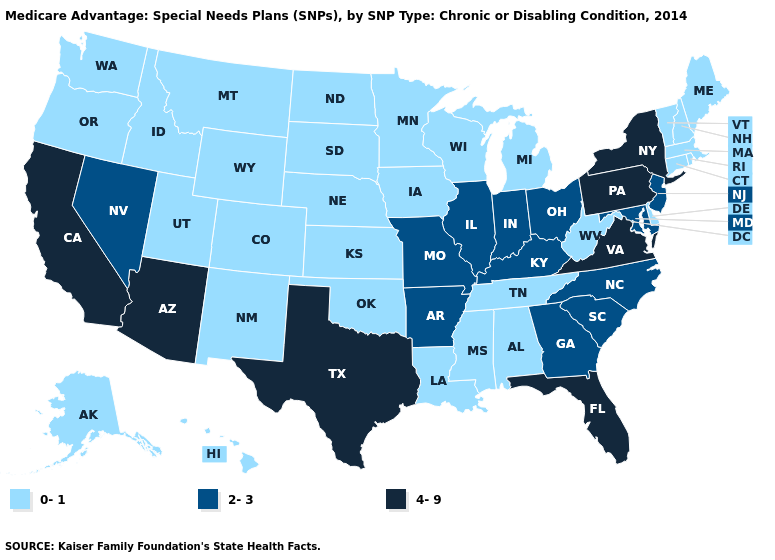Name the states that have a value in the range 2-3?
Short answer required. Arkansas, Georgia, Illinois, Indiana, Kentucky, Maryland, Missouri, North Carolina, New Jersey, Nevada, Ohio, South Carolina. Name the states that have a value in the range 0-1?
Quick response, please. Alaska, Alabama, Colorado, Connecticut, Delaware, Hawaii, Iowa, Idaho, Kansas, Louisiana, Massachusetts, Maine, Michigan, Minnesota, Mississippi, Montana, North Dakota, Nebraska, New Hampshire, New Mexico, Oklahoma, Oregon, Rhode Island, South Dakota, Tennessee, Utah, Vermont, Washington, Wisconsin, West Virginia, Wyoming. Is the legend a continuous bar?
Keep it brief. No. What is the value of Washington?
Be succinct. 0-1. What is the highest value in the USA?
Be succinct. 4-9. What is the value of Georgia?
Concise answer only. 2-3. What is the value of Colorado?
Be succinct. 0-1. Among the states that border Washington , which have the highest value?
Write a very short answer. Idaho, Oregon. Name the states that have a value in the range 2-3?
Answer briefly. Arkansas, Georgia, Illinois, Indiana, Kentucky, Maryland, Missouri, North Carolina, New Jersey, Nevada, Ohio, South Carolina. What is the highest value in the USA?
Be succinct. 4-9. Which states have the lowest value in the MidWest?
Short answer required. Iowa, Kansas, Michigan, Minnesota, North Dakota, Nebraska, South Dakota, Wisconsin. Among the states that border Kansas , which have the lowest value?
Short answer required. Colorado, Nebraska, Oklahoma. Does California have the highest value in the West?
Answer briefly. Yes. Does the map have missing data?
Short answer required. No. What is the value of Virginia?
Answer briefly. 4-9. 